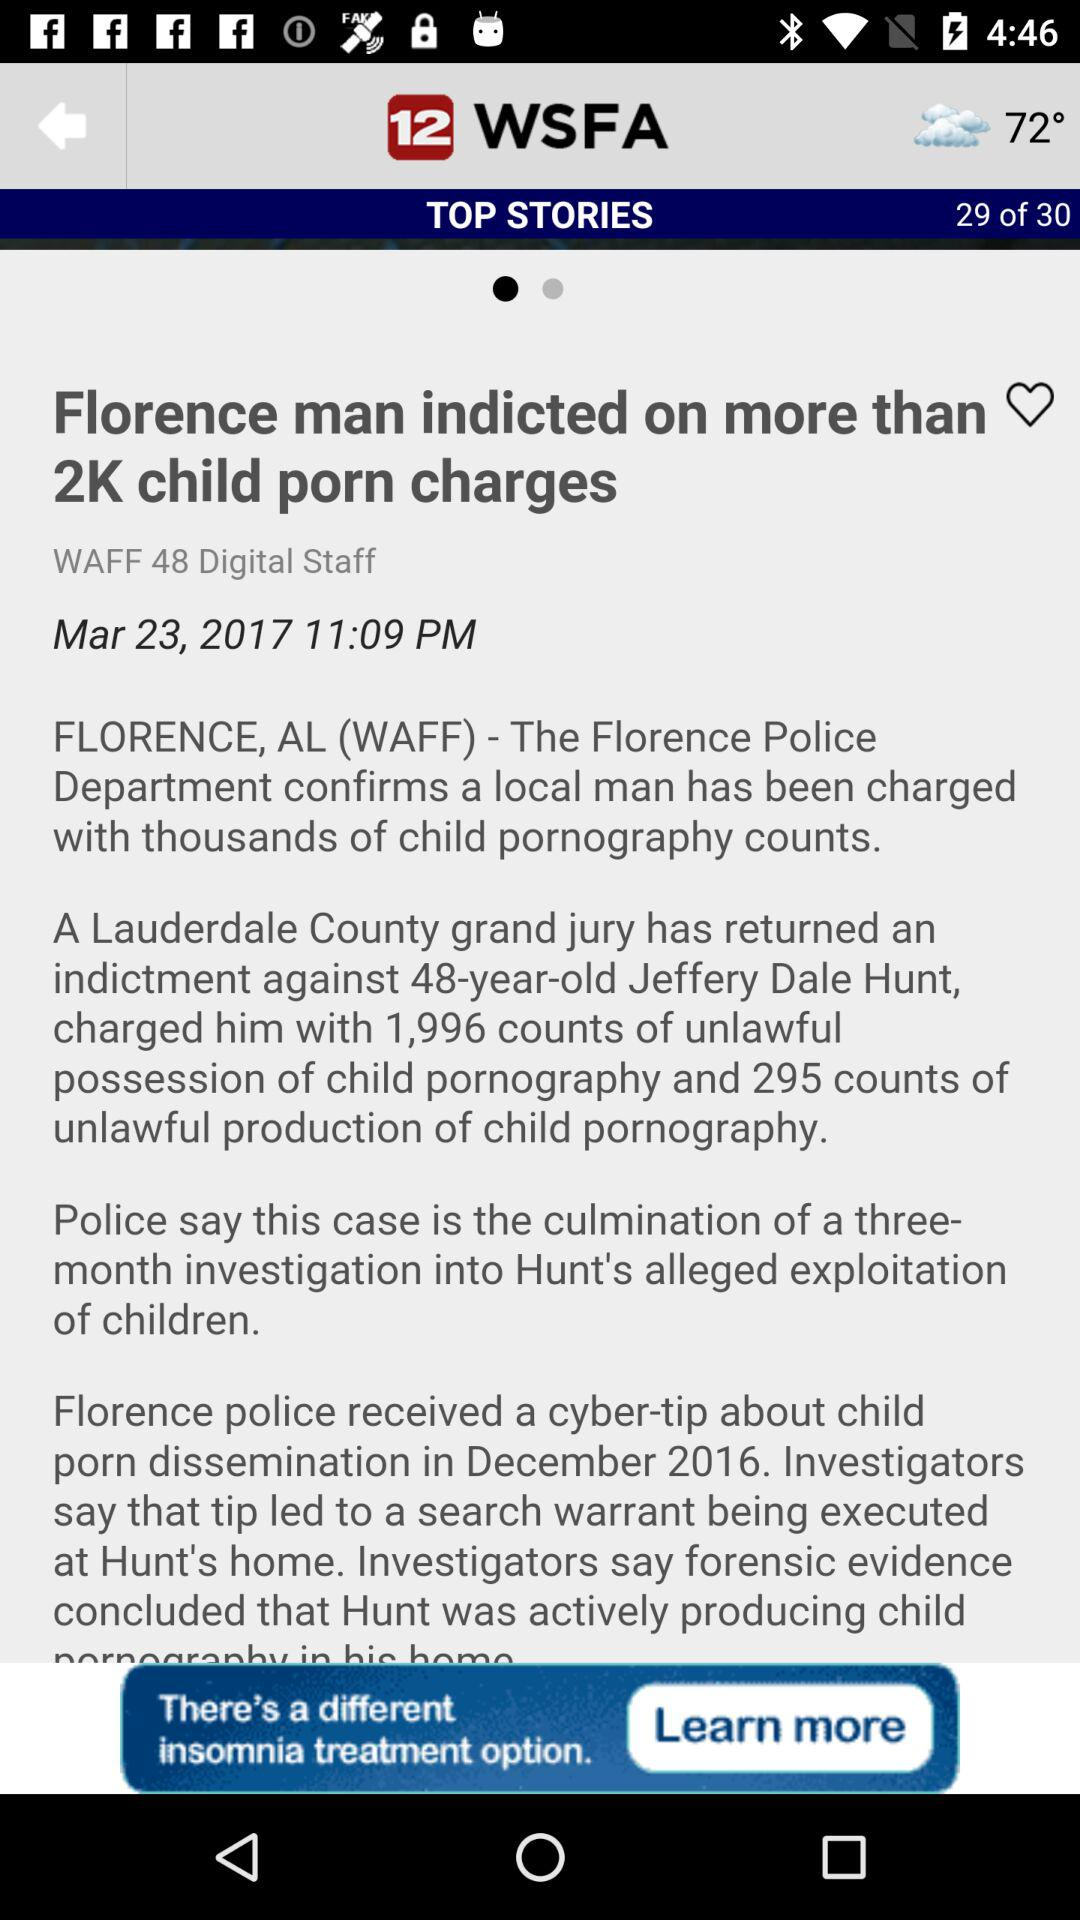When was the news posted? The news was posted on March 23, 2017, at 11:09 PM. 